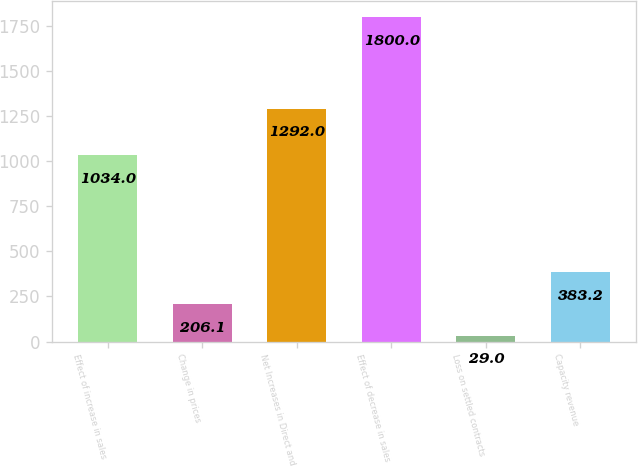Convert chart to OTSL. <chart><loc_0><loc_0><loc_500><loc_500><bar_chart><fcel>Effect of increase in sales<fcel>Change in prices<fcel>Net Increases in Direct and<fcel>Effect of decrease in sales<fcel>Loss on settled contracts<fcel>Capacity revenue<nl><fcel>1034<fcel>206.1<fcel>1292<fcel>1800<fcel>29<fcel>383.2<nl></chart> 